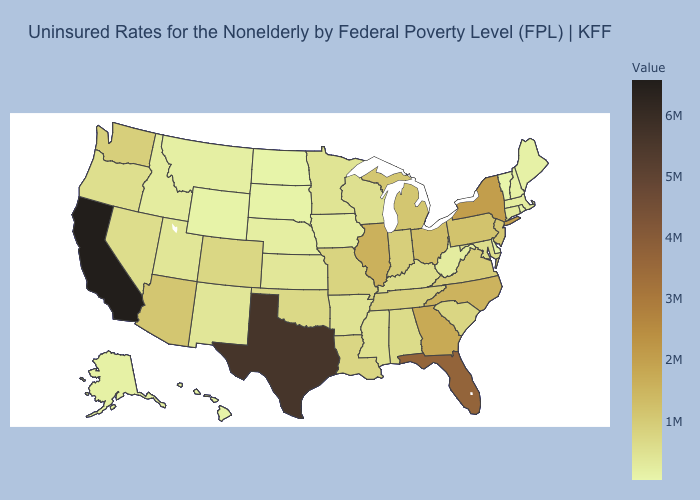Does Utah have a lower value than California?
Keep it brief. Yes. Among the states that border North Carolina , which have the highest value?
Concise answer only. Georgia. Does Florida have the highest value in the USA?
Concise answer only. No. 